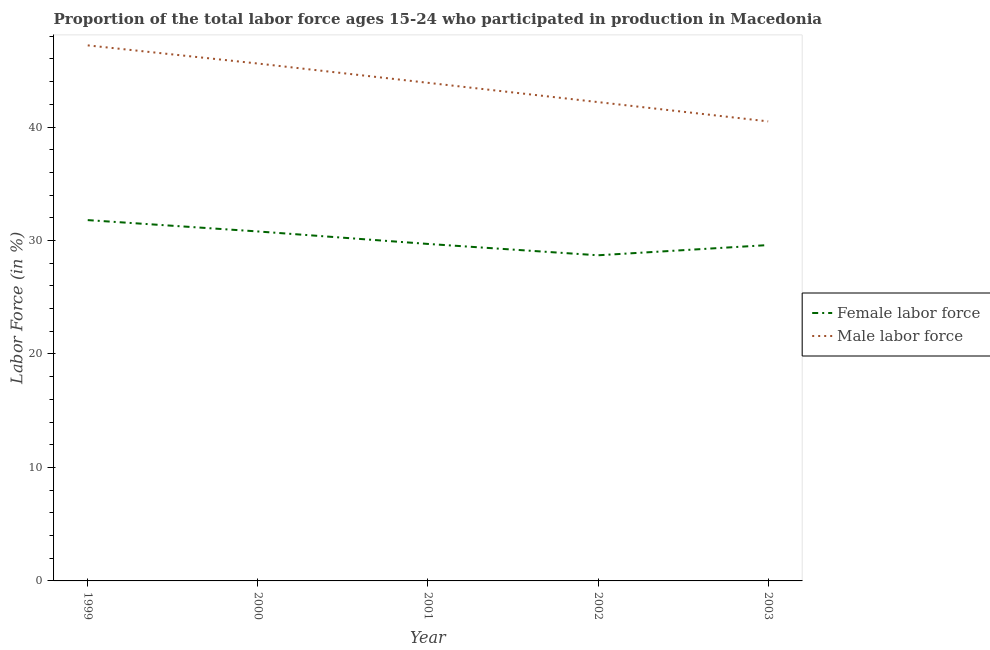How many different coloured lines are there?
Ensure brevity in your answer.  2. Does the line corresponding to percentage of female labor force intersect with the line corresponding to percentage of male labour force?
Make the answer very short. No. Is the number of lines equal to the number of legend labels?
Provide a short and direct response. Yes. What is the percentage of male labour force in 2002?
Provide a short and direct response. 42.2. Across all years, what is the maximum percentage of female labor force?
Offer a terse response. 31.8. Across all years, what is the minimum percentage of female labor force?
Provide a short and direct response. 28.7. In which year was the percentage of male labour force minimum?
Offer a terse response. 2003. What is the total percentage of female labor force in the graph?
Provide a short and direct response. 150.6. What is the difference between the percentage of male labour force in 2002 and that in 2003?
Your answer should be compact. 1.7. What is the difference between the percentage of female labor force in 1999 and the percentage of male labour force in 2002?
Give a very brief answer. -10.4. What is the average percentage of female labor force per year?
Keep it short and to the point. 30.12. In the year 2001, what is the difference between the percentage of male labour force and percentage of female labor force?
Ensure brevity in your answer.  14.2. In how many years, is the percentage of female labor force greater than 8 %?
Your answer should be very brief. 5. What is the ratio of the percentage of male labour force in 2001 to that in 2002?
Make the answer very short. 1.04. What is the difference between the highest and the second highest percentage of male labour force?
Give a very brief answer. 1.6. What is the difference between the highest and the lowest percentage of male labour force?
Your response must be concise. 6.7. Is the sum of the percentage of male labour force in 2000 and 2001 greater than the maximum percentage of female labor force across all years?
Give a very brief answer. Yes. Is the percentage of female labor force strictly less than the percentage of male labour force over the years?
Give a very brief answer. Yes. Does the graph contain any zero values?
Give a very brief answer. No. How many legend labels are there?
Offer a very short reply. 2. What is the title of the graph?
Your response must be concise. Proportion of the total labor force ages 15-24 who participated in production in Macedonia. Does "Young" appear as one of the legend labels in the graph?
Keep it short and to the point. No. What is the label or title of the X-axis?
Offer a terse response. Year. What is the label or title of the Y-axis?
Ensure brevity in your answer.  Labor Force (in %). What is the Labor Force (in %) in Female labor force in 1999?
Offer a terse response. 31.8. What is the Labor Force (in %) in Male labor force in 1999?
Your response must be concise. 47.2. What is the Labor Force (in %) in Female labor force in 2000?
Provide a short and direct response. 30.8. What is the Labor Force (in %) in Male labor force in 2000?
Your answer should be very brief. 45.6. What is the Labor Force (in %) of Female labor force in 2001?
Your answer should be compact. 29.7. What is the Labor Force (in %) in Male labor force in 2001?
Make the answer very short. 43.9. What is the Labor Force (in %) in Female labor force in 2002?
Make the answer very short. 28.7. What is the Labor Force (in %) of Male labor force in 2002?
Offer a terse response. 42.2. What is the Labor Force (in %) of Female labor force in 2003?
Provide a short and direct response. 29.6. What is the Labor Force (in %) in Male labor force in 2003?
Provide a succinct answer. 40.5. Across all years, what is the maximum Labor Force (in %) in Female labor force?
Give a very brief answer. 31.8. Across all years, what is the maximum Labor Force (in %) in Male labor force?
Ensure brevity in your answer.  47.2. Across all years, what is the minimum Labor Force (in %) of Female labor force?
Ensure brevity in your answer.  28.7. Across all years, what is the minimum Labor Force (in %) of Male labor force?
Provide a short and direct response. 40.5. What is the total Labor Force (in %) in Female labor force in the graph?
Ensure brevity in your answer.  150.6. What is the total Labor Force (in %) in Male labor force in the graph?
Provide a short and direct response. 219.4. What is the difference between the Labor Force (in %) of Female labor force in 1999 and that in 2000?
Keep it short and to the point. 1. What is the difference between the Labor Force (in %) in Female labor force in 1999 and that in 2001?
Offer a very short reply. 2.1. What is the difference between the Labor Force (in %) in Male labor force in 1999 and that in 2001?
Your response must be concise. 3.3. What is the difference between the Labor Force (in %) in Female labor force in 1999 and that in 2002?
Provide a short and direct response. 3.1. What is the difference between the Labor Force (in %) in Male labor force in 1999 and that in 2002?
Offer a very short reply. 5. What is the difference between the Labor Force (in %) of Female labor force in 1999 and that in 2003?
Your answer should be very brief. 2.2. What is the difference between the Labor Force (in %) in Male labor force in 1999 and that in 2003?
Provide a succinct answer. 6.7. What is the difference between the Labor Force (in %) of Female labor force in 2000 and that in 2001?
Ensure brevity in your answer.  1.1. What is the difference between the Labor Force (in %) of Male labor force in 2000 and that in 2001?
Keep it short and to the point. 1.7. What is the difference between the Labor Force (in %) of Female labor force in 2000 and that in 2003?
Your answer should be very brief. 1.2. What is the difference between the Labor Force (in %) in Male labor force in 2000 and that in 2003?
Provide a succinct answer. 5.1. What is the difference between the Labor Force (in %) in Female labor force in 2001 and that in 2002?
Provide a short and direct response. 1. What is the difference between the Labor Force (in %) of Male labor force in 2001 and that in 2002?
Offer a terse response. 1.7. What is the difference between the Labor Force (in %) of Female labor force in 2001 and that in 2003?
Ensure brevity in your answer.  0.1. What is the difference between the Labor Force (in %) in Male labor force in 2001 and that in 2003?
Ensure brevity in your answer.  3.4. What is the difference between the Labor Force (in %) of Female labor force in 1999 and the Labor Force (in %) of Male labor force in 2000?
Your answer should be compact. -13.8. What is the difference between the Labor Force (in %) of Female labor force in 1999 and the Labor Force (in %) of Male labor force in 2003?
Keep it short and to the point. -8.7. What is the difference between the Labor Force (in %) of Female labor force in 2000 and the Labor Force (in %) of Male labor force in 2001?
Ensure brevity in your answer.  -13.1. What is the difference between the Labor Force (in %) of Female labor force in 2000 and the Labor Force (in %) of Male labor force in 2003?
Keep it short and to the point. -9.7. What is the difference between the Labor Force (in %) of Female labor force in 2001 and the Labor Force (in %) of Male labor force in 2003?
Your answer should be compact. -10.8. What is the average Labor Force (in %) in Female labor force per year?
Your answer should be compact. 30.12. What is the average Labor Force (in %) of Male labor force per year?
Your response must be concise. 43.88. In the year 1999, what is the difference between the Labor Force (in %) of Female labor force and Labor Force (in %) of Male labor force?
Provide a succinct answer. -15.4. In the year 2000, what is the difference between the Labor Force (in %) in Female labor force and Labor Force (in %) in Male labor force?
Your answer should be compact. -14.8. In the year 2001, what is the difference between the Labor Force (in %) of Female labor force and Labor Force (in %) of Male labor force?
Ensure brevity in your answer.  -14.2. In the year 2003, what is the difference between the Labor Force (in %) in Female labor force and Labor Force (in %) in Male labor force?
Your answer should be very brief. -10.9. What is the ratio of the Labor Force (in %) of Female labor force in 1999 to that in 2000?
Offer a terse response. 1.03. What is the ratio of the Labor Force (in %) of Male labor force in 1999 to that in 2000?
Provide a short and direct response. 1.04. What is the ratio of the Labor Force (in %) in Female labor force in 1999 to that in 2001?
Give a very brief answer. 1.07. What is the ratio of the Labor Force (in %) in Male labor force in 1999 to that in 2001?
Your answer should be compact. 1.08. What is the ratio of the Labor Force (in %) of Female labor force in 1999 to that in 2002?
Your answer should be compact. 1.11. What is the ratio of the Labor Force (in %) of Male labor force in 1999 to that in 2002?
Give a very brief answer. 1.12. What is the ratio of the Labor Force (in %) in Female labor force in 1999 to that in 2003?
Give a very brief answer. 1.07. What is the ratio of the Labor Force (in %) in Male labor force in 1999 to that in 2003?
Give a very brief answer. 1.17. What is the ratio of the Labor Force (in %) of Male labor force in 2000 to that in 2001?
Ensure brevity in your answer.  1.04. What is the ratio of the Labor Force (in %) of Female labor force in 2000 to that in 2002?
Keep it short and to the point. 1.07. What is the ratio of the Labor Force (in %) of Male labor force in 2000 to that in 2002?
Give a very brief answer. 1.08. What is the ratio of the Labor Force (in %) in Female labor force in 2000 to that in 2003?
Offer a terse response. 1.04. What is the ratio of the Labor Force (in %) in Male labor force in 2000 to that in 2003?
Provide a short and direct response. 1.13. What is the ratio of the Labor Force (in %) in Female labor force in 2001 to that in 2002?
Your answer should be very brief. 1.03. What is the ratio of the Labor Force (in %) in Male labor force in 2001 to that in 2002?
Offer a terse response. 1.04. What is the ratio of the Labor Force (in %) in Female labor force in 2001 to that in 2003?
Keep it short and to the point. 1. What is the ratio of the Labor Force (in %) in Male labor force in 2001 to that in 2003?
Your response must be concise. 1.08. What is the ratio of the Labor Force (in %) of Female labor force in 2002 to that in 2003?
Your answer should be compact. 0.97. What is the ratio of the Labor Force (in %) in Male labor force in 2002 to that in 2003?
Offer a very short reply. 1.04. 